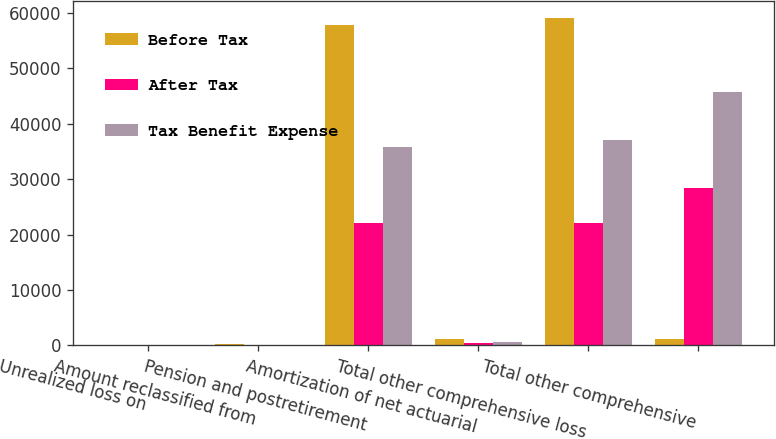Convert chart. <chart><loc_0><loc_0><loc_500><loc_500><stacked_bar_chart><ecel><fcel>Unrealized loss on<fcel>Amount reclassified from<fcel>Pension and postretirement<fcel>Amortization of net actuarial<fcel>Total other comprehensive loss<fcel>Total other comprehensive<nl><fcel>Before Tax<fcel>57<fcel>257<fcel>57769<fcel>1134<fcel>59112<fcel>1134<nl><fcel>After Tax<fcel>22<fcel>99<fcel>22064<fcel>435<fcel>22086<fcel>28322<nl><fcel>Tax Benefit Expense<fcel>35<fcel>158<fcel>35705<fcel>699<fcel>37026<fcel>45672<nl></chart> 